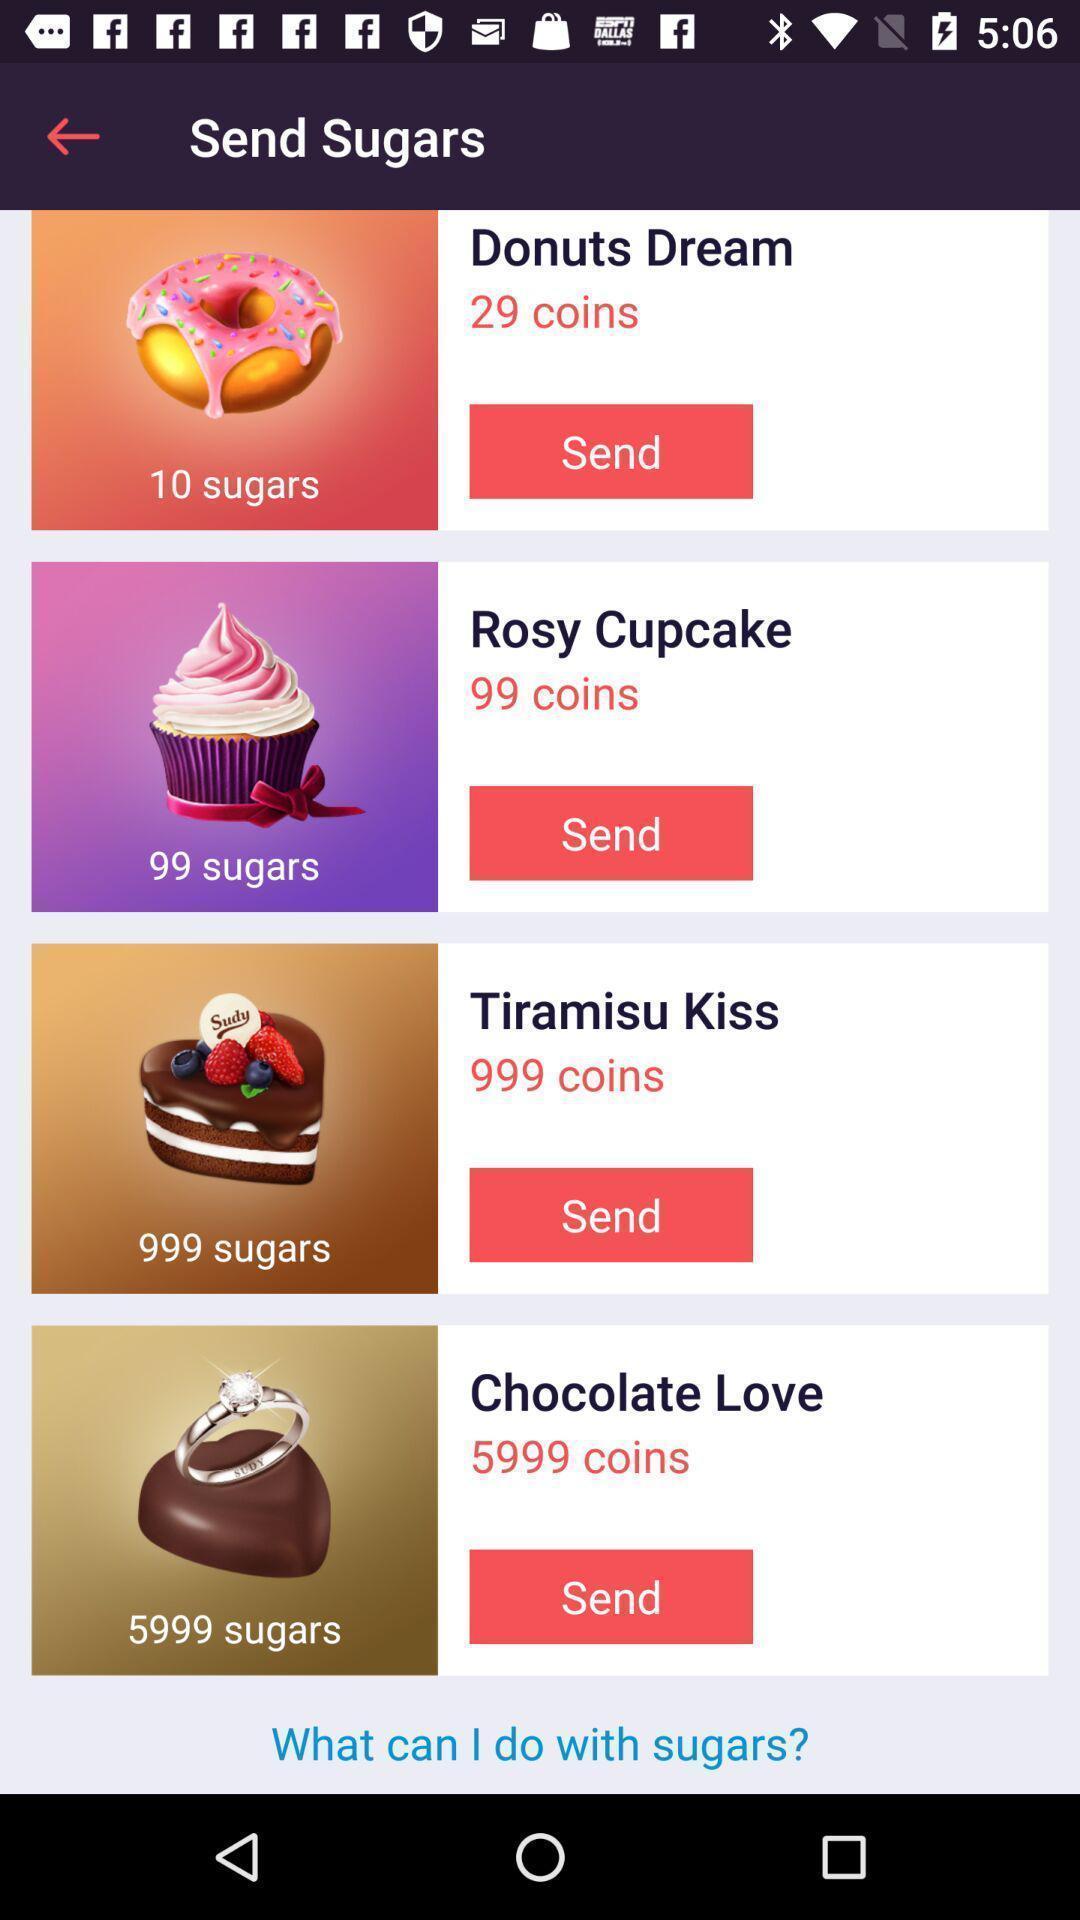Describe this image in words. Screen showing send sugars. 